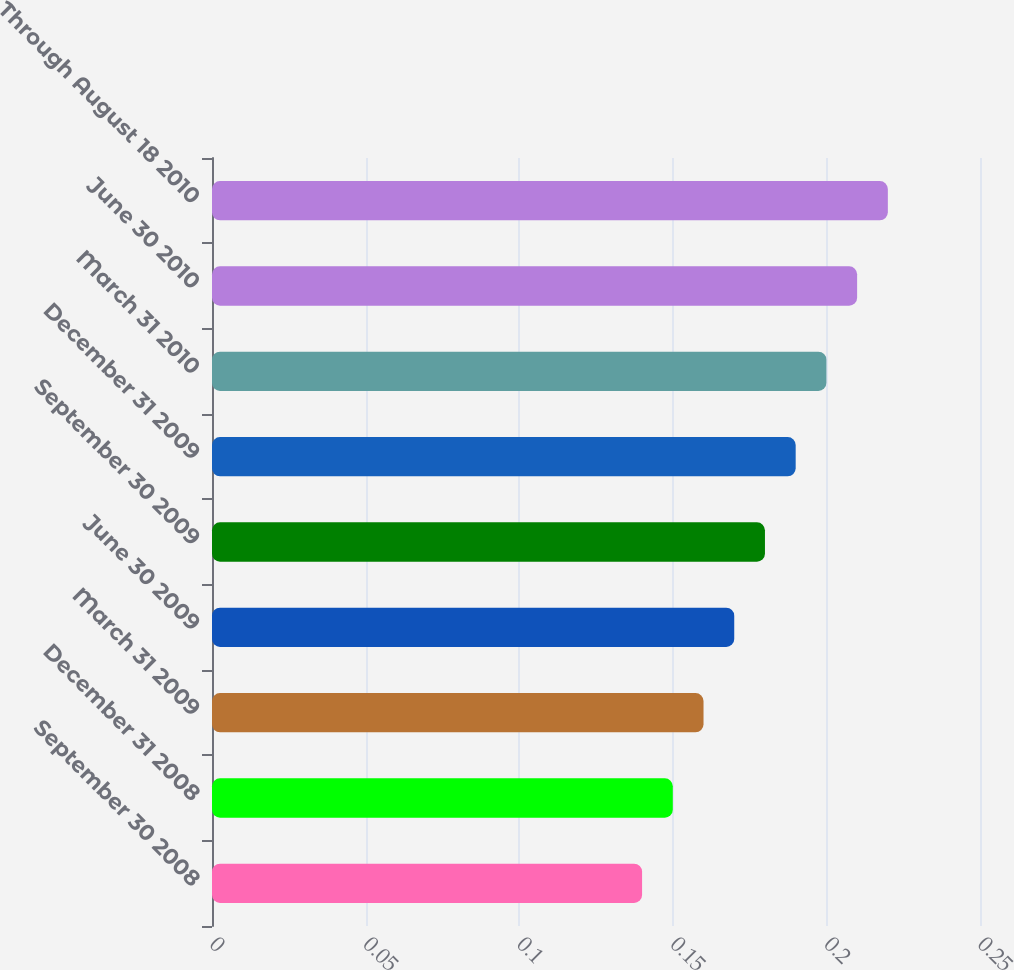<chart> <loc_0><loc_0><loc_500><loc_500><bar_chart><fcel>September 30 2008<fcel>December 31 2008<fcel>March 31 2009<fcel>June 30 2009<fcel>September 30 2009<fcel>December 31 2009<fcel>March 31 2010<fcel>June 30 2010<fcel>Through August 18 2010<nl><fcel>0.14<fcel>0.15<fcel>0.16<fcel>0.17<fcel>0.18<fcel>0.19<fcel>0.2<fcel>0.21<fcel>0.22<nl></chart> 